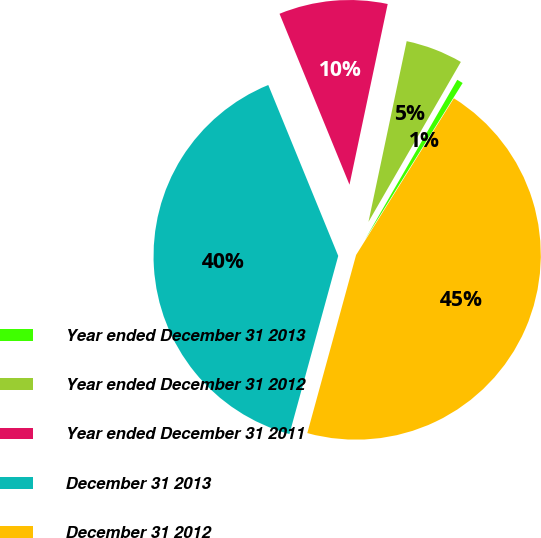Convert chart. <chart><loc_0><loc_0><loc_500><loc_500><pie_chart><fcel>Year ended December 31 2013<fcel>Year ended December 31 2012<fcel>Year ended December 31 2011<fcel>December 31 2013<fcel>December 31 2012<nl><fcel>0.54%<fcel>5.02%<fcel>9.5%<fcel>39.56%<fcel>45.38%<nl></chart> 